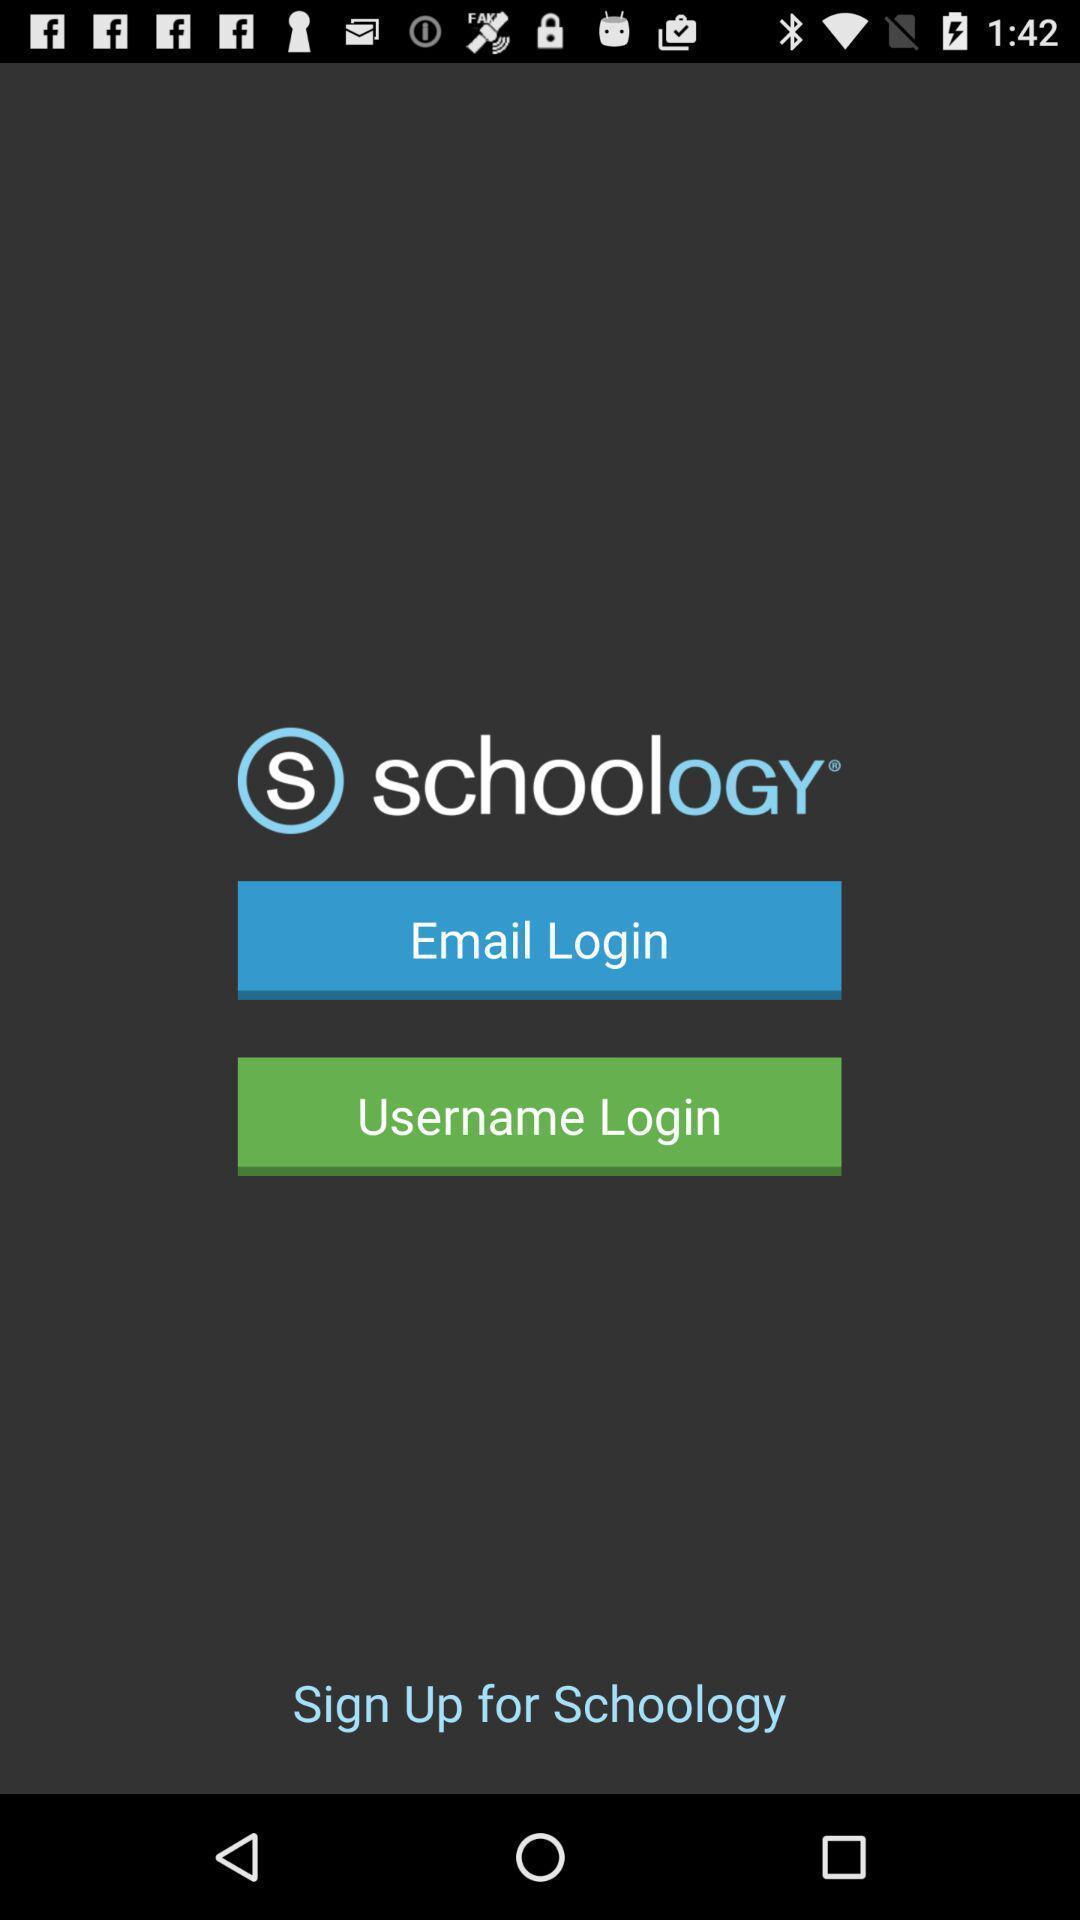Describe the content in this image. Welcome page displaying to login of an educational application. 